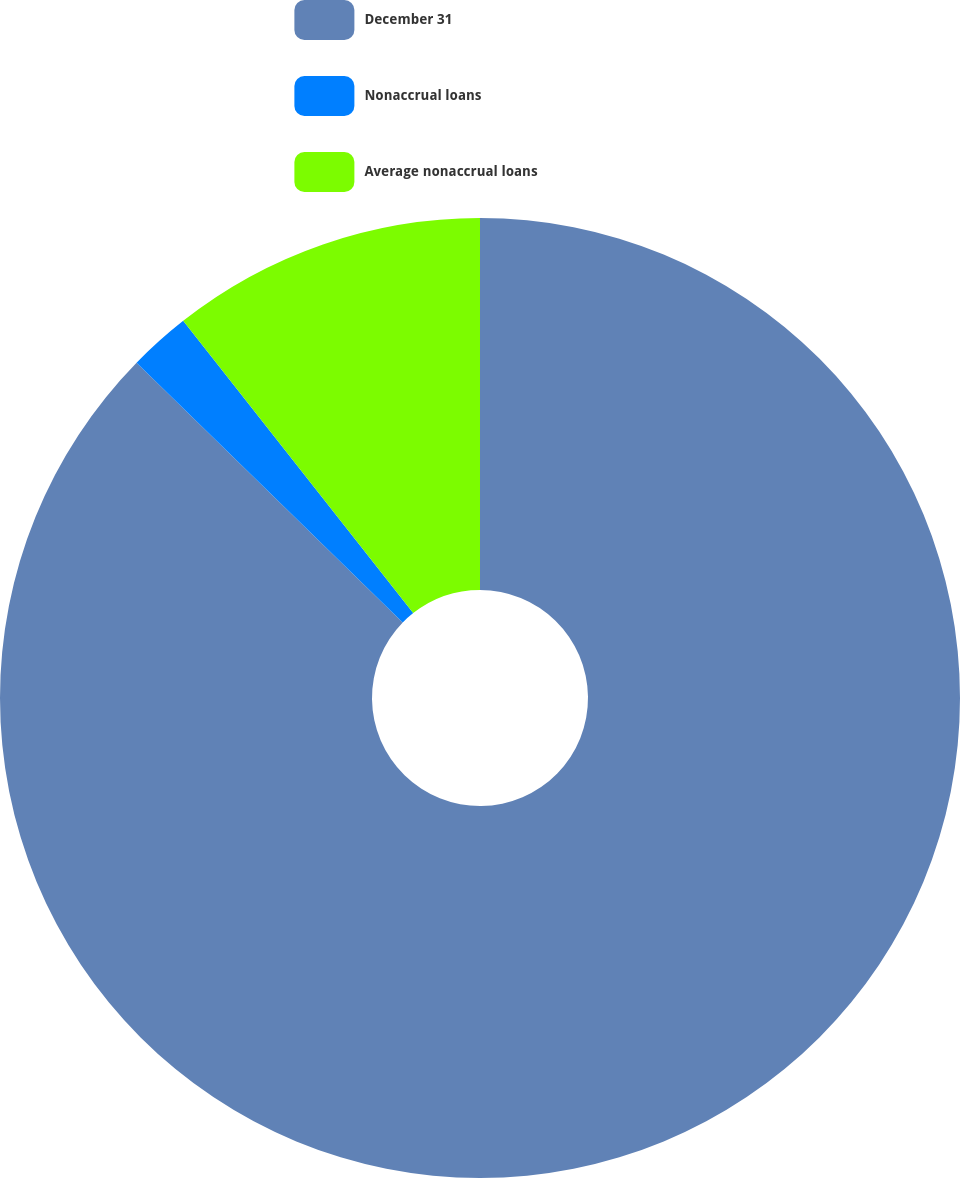<chart> <loc_0><loc_0><loc_500><loc_500><pie_chart><fcel>December 31<fcel>Nonaccrual loans<fcel>Average nonaccrual loans<nl><fcel>87.31%<fcel>2.08%<fcel>10.61%<nl></chart> 